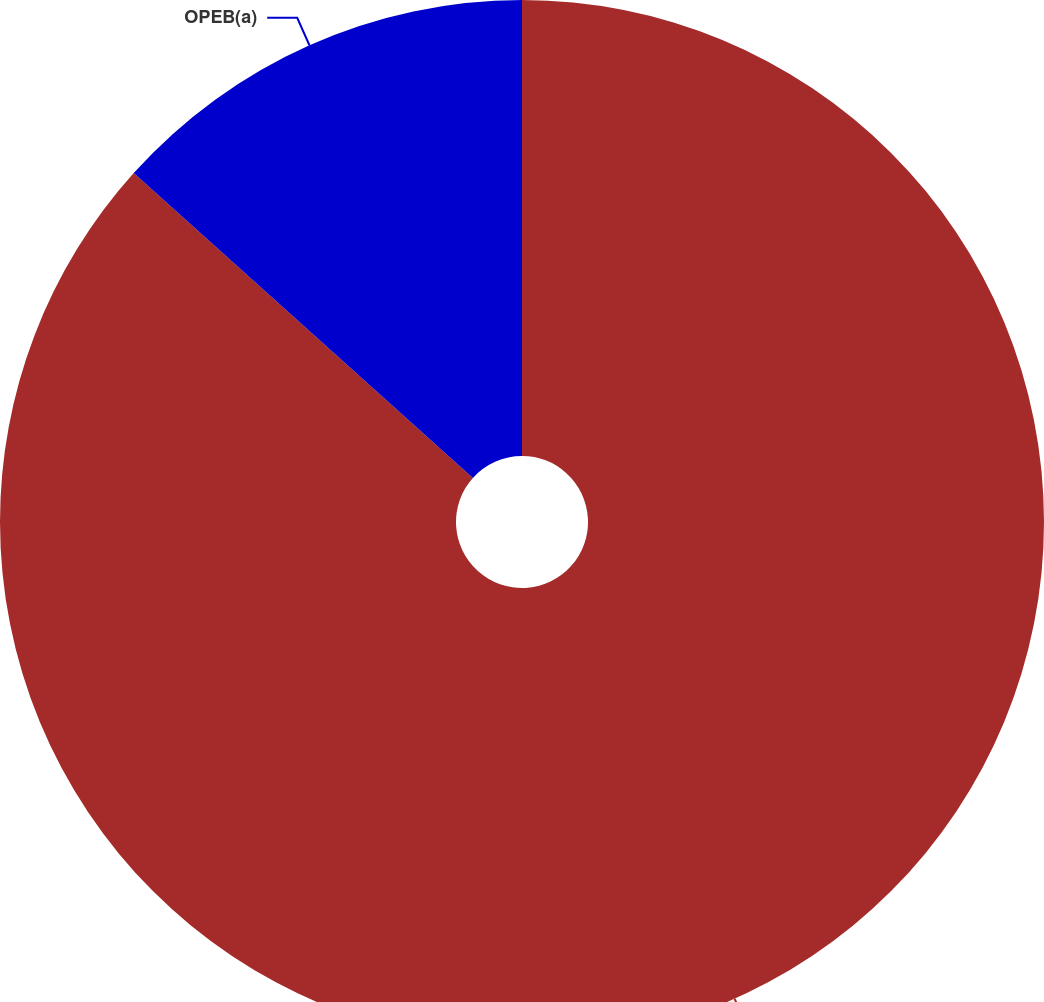Convert chart to OTSL. <chart><loc_0><loc_0><loc_500><loc_500><pie_chart><fcel>Benefits<fcel>OPEB(a)<nl><fcel>86.65%<fcel>13.35%<nl></chart> 